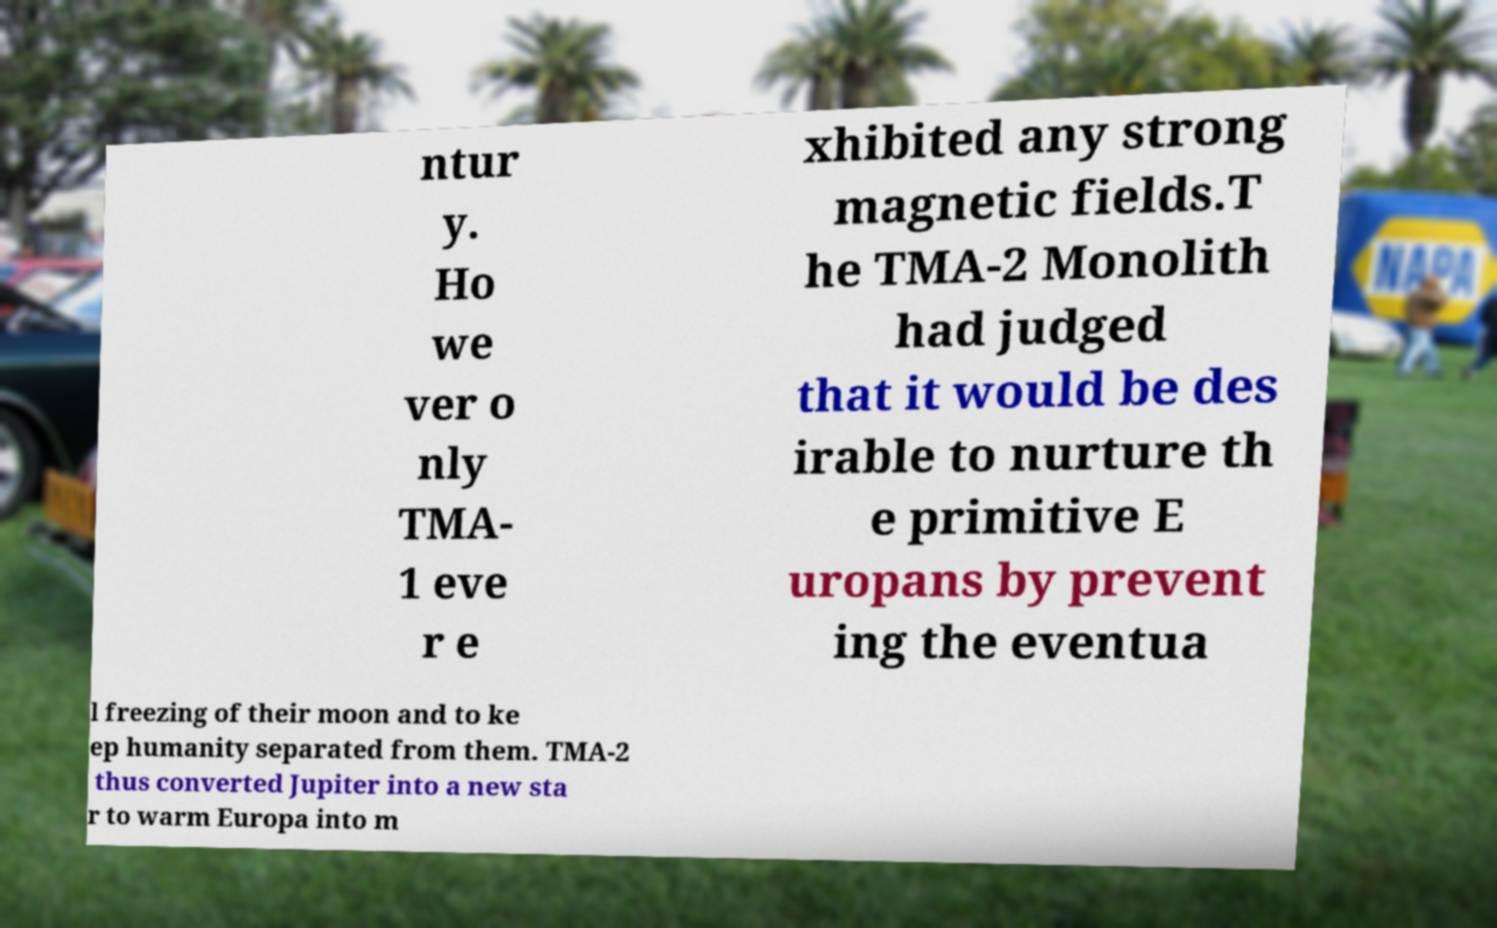Can you read and provide the text displayed in the image?This photo seems to have some interesting text. Can you extract and type it out for me? ntur y. Ho we ver o nly TMA- 1 eve r e xhibited any strong magnetic fields.T he TMA-2 Monolith had judged that it would be des irable to nurture th e primitive E uropans by prevent ing the eventua l freezing of their moon and to ke ep humanity separated from them. TMA-2 thus converted Jupiter into a new sta r to warm Europa into m 